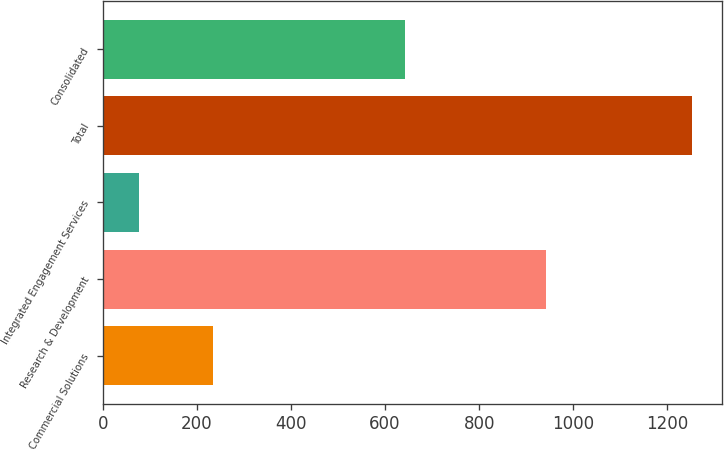Convert chart to OTSL. <chart><loc_0><loc_0><loc_500><loc_500><bar_chart><fcel>Commercial Solutions<fcel>Research & Development<fcel>Integrated Engagement Services<fcel>Total<fcel>Consolidated<nl><fcel>234<fcel>943<fcel>76<fcel>1253<fcel>642<nl></chart> 